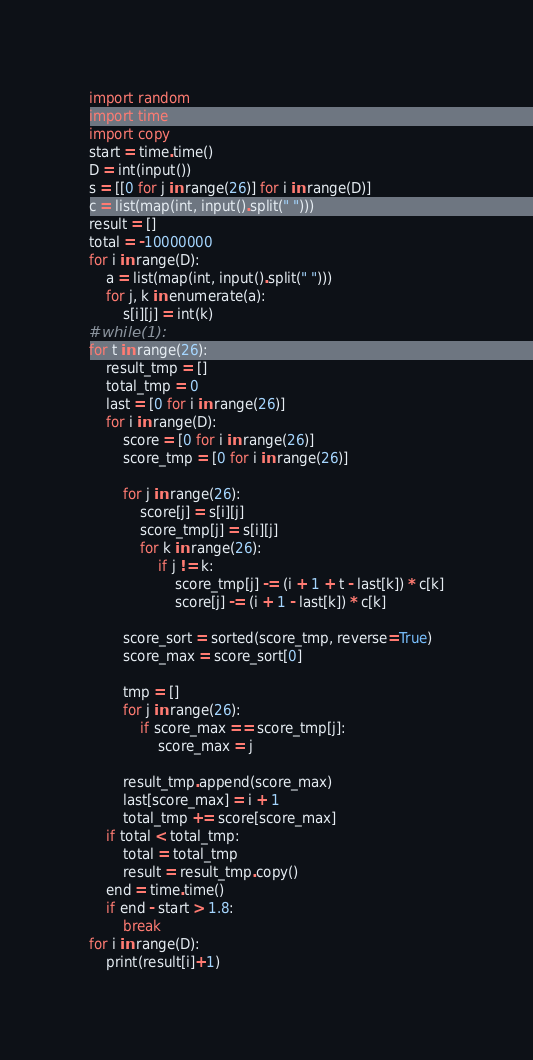<code> <loc_0><loc_0><loc_500><loc_500><_Python_>import random
import time
import copy
start = time.time()
D = int(input())
s = [[0 for j in range(26)] for i in range(D)]
c = list(map(int, input().split(" ")))
result = []
total = -10000000
for i in range(D):
    a = list(map(int, input().split(" ")))
    for j, k in enumerate(a):
        s[i][j] = int(k)
#while(1):
for t in range(26):
    result_tmp = []
    total_tmp = 0
    last = [0 for i in range(26)]
    for i in range(D):
        score = [0 for i in range(26)]
        score_tmp = [0 for i in range(26)]

        for j in range(26):
            score[j] = s[i][j]
            score_tmp[j] = s[i][j]
            for k in range(26):
                if j != k:
                    score_tmp[j] -= (i + 1 + t - last[k]) * c[k]
                    score[j] -= (i + 1 - last[k]) * c[k]

        score_sort = sorted(score_tmp, reverse=True)
        score_max = score_sort[0]

        tmp = []
        for j in range(26):
            if score_max == score_tmp[j]:
                score_max = j

        result_tmp.append(score_max)
        last[score_max] = i + 1
        total_tmp += score[score_max]
    if total < total_tmp:
        total = total_tmp
        result = result_tmp.copy()
    end = time.time()
    if end - start > 1.8:
        break
for i in range(D):
    print(result[i]+1)</code> 